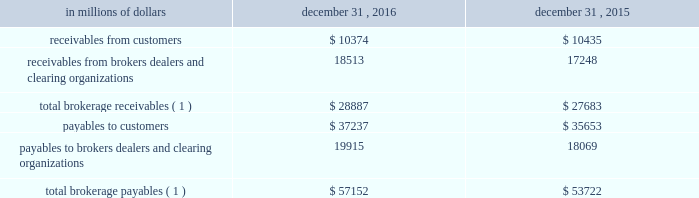12 .
Brokerage receivables and brokerage payables citi has receivables and payables for financial instruments sold to and purchased from brokers , dealers and customers , which arise in the ordinary course of business .
Citi is exposed to risk of loss from the inability of brokers , dealers or customers to pay for purchases or to deliver the financial instruments sold , in which case citi would have to sell or purchase the financial instruments at prevailing market prices .
Credit risk is reduced to the extent that an exchange or clearing organization acts as a counterparty to the transaction and replaces the broker , dealer or customer in question .
Citi seeks to protect itself from the risks associated with customer activities by requiring customers to maintain margin collateral in compliance with regulatory and internal guidelines .
Margin levels are monitored daily , and customers deposit additional collateral as required .
Where customers cannot meet collateral requirements , citi may liquidate sufficient underlying financial instruments to bring the customer into compliance with the required margin level .
Exposure to credit risk is impacted by market volatility , which may impair the ability of clients to satisfy their obligations to citi .
Credit limits are established and closely monitored for customers and for brokers and dealers engaged in forwards , futures and other transactions deemed to be credit sensitive .
Brokerage receivables and brokerage payables consisted of the following: .
Payables to brokers , dealers , and clearing organizations 19915 18069 total brokerage payables ( 1 ) $ 57152 $ 53722 ( 1 ) includes brokerage receivables and payables recorded by citi broker- dealer entities that are accounted for in accordance with the aicpa accounting guide for brokers and dealers in securities as codified in asc 940-320. .
As of december 31 , 2015 what was the ratio of receivables from brokers dealers and clearing organizations to payables to brokers dealers and clearing organizations? 
Computations: (17248 / 18069)
Answer: 0.95456. 